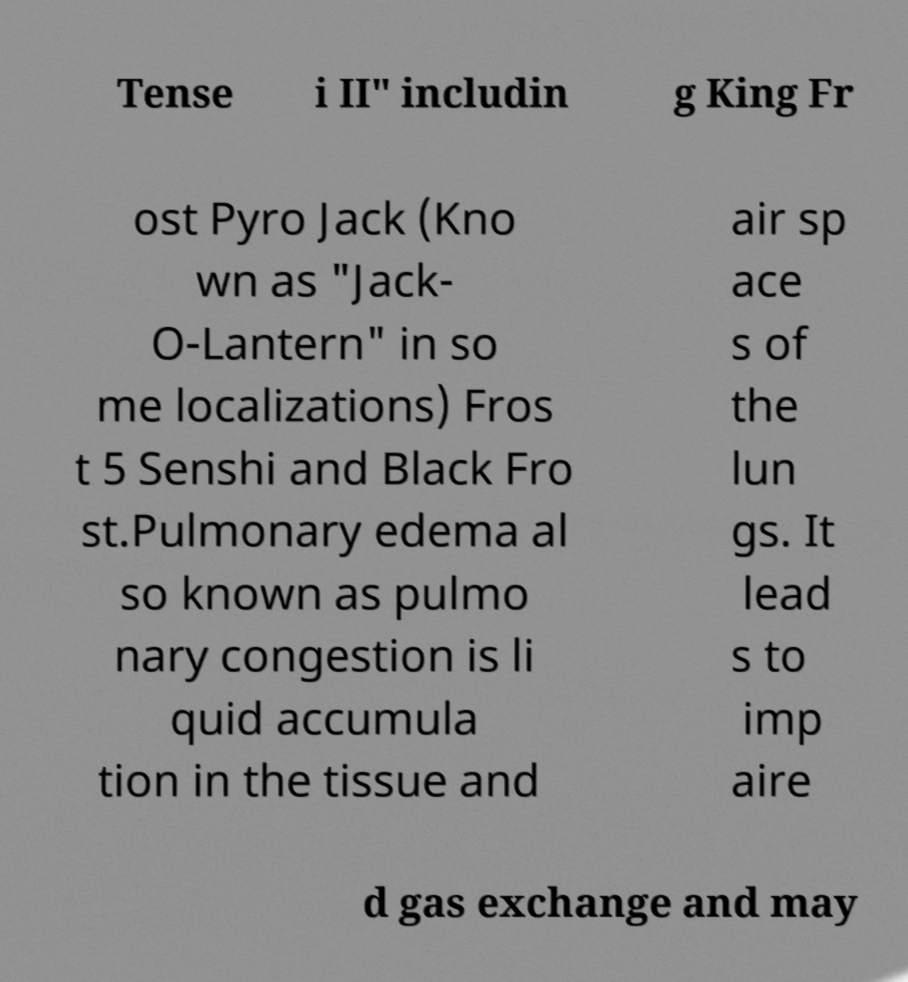Please read and relay the text visible in this image. What does it say? Tense i II" includin g King Fr ost Pyro Jack (Kno wn as "Jack- O-Lantern" in so me localizations) Fros t 5 Senshi and Black Fro st.Pulmonary edema al so known as pulmo nary congestion is li quid accumula tion in the tissue and air sp ace s of the lun gs. It lead s to imp aire d gas exchange and may 